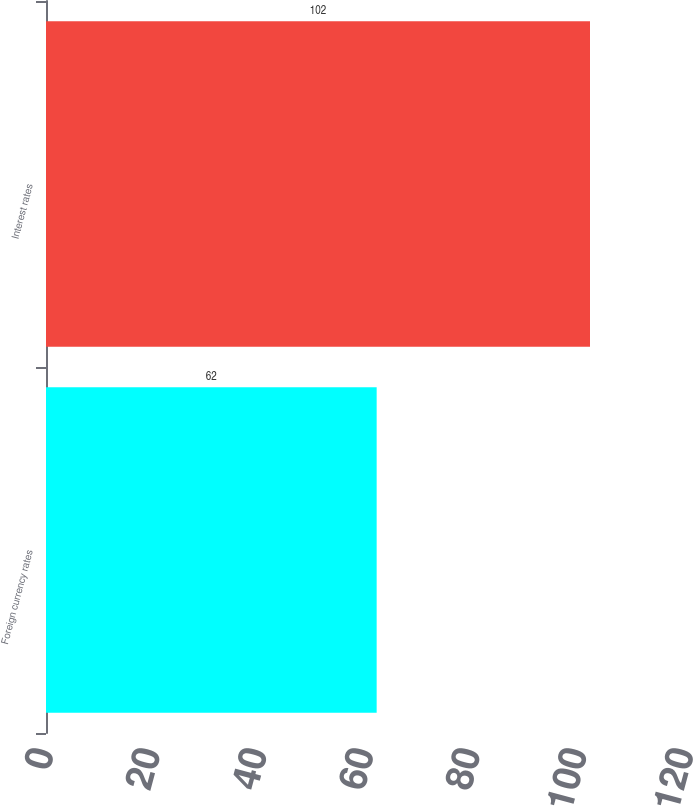Convert chart to OTSL. <chart><loc_0><loc_0><loc_500><loc_500><bar_chart><fcel>Foreign currency rates<fcel>Interest rates<nl><fcel>62<fcel>102<nl></chart> 